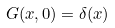Convert formula to latex. <formula><loc_0><loc_0><loc_500><loc_500>G ( x , 0 ) = \delta ( x )</formula> 